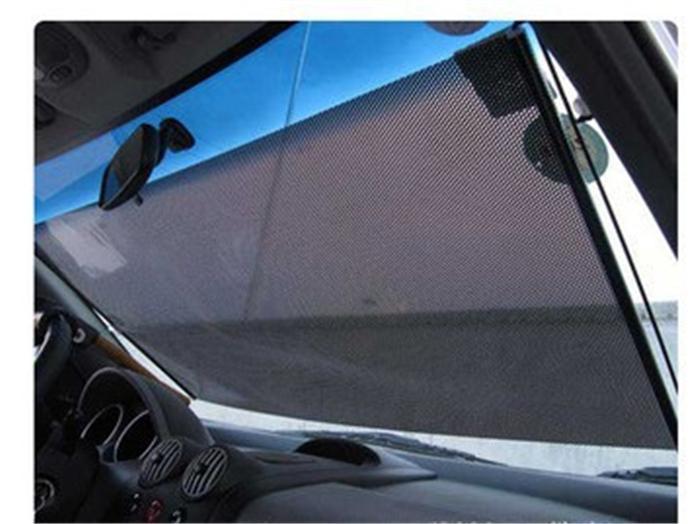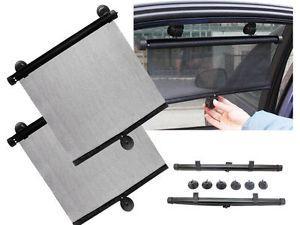The first image is the image on the left, the second image is the image on the right. For the images displayed, is the sentence "At least one hand shows how to adjust a car window shade with two suction cups at the top and one at the bottom." factually correct? Answer yes or no. Yes. 